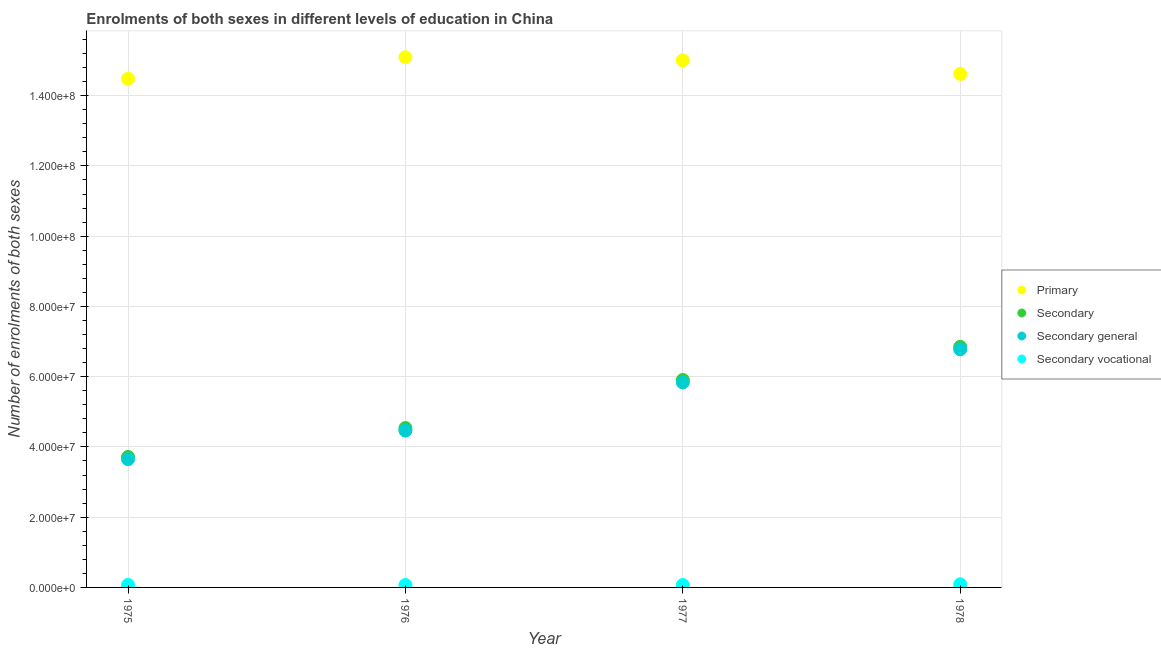How many different coloured dotlines are there?
Your answer should be very brief. 4. Is the number of dotlines equal to the number of legend labels?
Your answer should be very brief. Yes. What is the number of enrolments in secondary general education in 1975?
Make the answer very short. 3.65e+07. Across all years, what is the maximum number of enrolments in secondary vocational education?
Your answer should be compact. 8.89e+05. Across all years, what is the minimum number of enrolments in primary education?
Offer a very short reply. 1.45e+08. In which year was the number of enrolments in secondary education maximum?
Your answer should be very brief. 1978. In which year was the number of enrolments in secondary general education minimum?
Make the answer very short. 1975. What is the total number of enrolments in secondary general education in the graph?
Your response must be concise. 2.07e+08. What is the difference between the number of enrolments in secondary general education in 1975 and that in 1978?
Give a very brief answer. -3.13e+07. What is the difference between the number of enrolments in secondary education in 1978 and the number of enrolments in secondary vocational education in 1977?
Ensure brevity in your answer.  6.78e+07. What is the average number of enrolments in secondary general education per year?
Provide a succinct answer. 5.18e+07. In the year 1978, what is the difference between the number of enrolments in secondary vocational education and number of enrolments in primary education?
Offer a terse response. -1.45e+08. In how many years, is the number of enrolments in secondary general education greater than 140000000?
Offer a terse response. 0. What is the ratio of the number of enrolments in secondary vocational education in 1976 to that in 1977?
Your response must be concise. 1. Is the number of enrolments in secondary general education in 1975 less than that in 1976?
Offer a very short reply. Yes. What is the difference between the highest and the second highest number of enrolments in secondary education?
Your response must be concise. 9.43e+06. What is the difference between the highest and the lowest number of enrolments in secondary general education?
Offer a terse response. 3.13e+07. In how many years, is the number of enrolments in secondary general education greater than the average number of enrolments in secondary general education taken over all years?
Keep it short and to the point. 2. Is the sum of the number of enrolments in secondary education in 1976 and 1977 greater than the maximum number of enrolments in secondary general education across all years?
Ensure brevity in your answer.  Yes. Is it the case that in every year, the sum of the number of enrolments in secondary vocational education and number of enrolments in secondary education is greater than the sum of number of enrolments in secondary general education and number of enrolments in primary education?
Offer a very short reply. Yes. Is it the case that in every year, the sum of the number of enrolments in primary education and number of enrolments in secondary education is greater than the number of enrolments in secondary general education?
Your answer should be very brief. Yes. Does the number of enrolments in secondary vocational education monotonically increase over the years?
Your answer should be very brief. No. How many dotlines are there?
Your answer should be very brief. 4. Are the values on the major ticks of Y-axis written in scientific E-notation?
Make the answer very short. Yes. Does the graph contain any zero values?
Make the answer very short. No. Does the graph contain grids?
Your response must be concise. Yes. How many legend labels are there?
Offer a very short reply. 4. How are the legend labels stacked?
Ensure brevity in your answer.  Vertical. What is the title of the graph?
Keep it short and to the point. Enrolments of both sexes in different levels of education in China. What is the label or title of the X-axis?
Provide a succinct answer. Year. What is the label or title of the Y-axis?
Offer a terse response. Number of enrolments of both sexes. What is the Number of enrolments of both sexes of Primary in 1975?
Make the answer very short. 1.45e+08. What is the Number of enrolments of both sexes of Secondary in 1975?
Your answer should be very brief. 3.71e+07. What is the Number of enrolments of both sexes in Secondary general in 1975?
Make the answer very short. 3.65e+07. What is the Number of enrolments of both sexes in Secondary vocational in 1975?
Offer a terse response. 7.07e+05. What is the Number of enrolments of both sexes of Primary in 1976?
Your response must be concise. 1.51e+08. What is the Number of enrolments of both sexes of Secondary in 1976?
Make the answer very short. 4.54e+07. What is the Number of enrolments of both sexes in Secondary general in 1976?
Your answer should be compact. 4.47e+07. What is the Number of enrolments of both sexes of Secondary vocational in 1976?
Your answer should be compact. 6.90e+05. What is the Number of enrolments of both sexes in Primary in 1977?
Your answer should be compact. 1.50e+08. What is the Number of enrolments of both sexes in Secondary in 1977?
Keep it short and to the point. 5.91e+07. What is the Number of enrolments of both sexes of Secondary general in 1977?
Offer a very short reply. 5.84e+07. What is the Number of enrolments of both sexes of Secondary vocational in 1977?
Your answer should be compact. 6.89e+05. What is the Number of enrolments of both sexes of Primary in 1978?
Offer a very short reply. 1.46e+08. What is the Number of enrolments of both sexes in Secondary in 1978?
Give a very brief answer. 6.85e+07. What is the Number of enrolments of both sexes of Secondary general in 1978?
Provide a short and direct response. 6.78e+07. What is the Number of enrolments of both sexes of Secondary vocational in 1978?
Give a very brief answer. 8.89e+05. Across all years, what is the maximum Number of enrolments of both sexes in Primary?
Your answer should be very brief. 1.51e+08. Across all years, what is the maximum Number of enrolments of both sexes in Secondary?
Ensure brevity in your answer.  6.85e+07. Across all years, what is the maximum Number of enrolments of both sexes of Secondary general?
Provide a short and direct response. 6.78e+07. Across all years, what is the maximum Number of enrolments of both sexes in Secondary vocational?
Provide a short and direct response. 8.89e+05. Across all years, what is the minimum Number of enrolments of both sexes in Primary?
Provide a short and direct response. 1.45e+08. Across all years, what is the minimum Number of enrolments of both sexes in Secondary?
Keep it short and to the point. 3.71e+07. Across all years, what is the minimum Number of enrolments of both sexes of Secondary general?
Offer a very short reply. 3.65e+07. Across all years, what is the minimum Number of enrolments of both sexes in Secondary vocational?
Your response must be concise. 6.89e+05. What is the total Number of enrolments of both sexes in Primary in the graph?
Offer a very short reply. 5.92e+08. What is the total Number of enrolments of both sexes in Secondary in the graph?
Keep it short and to the point. 2.10e+08. What is the total Number of enrolments of both sexes in Secondary general in the graph?
Offer a terse response. 2.07e+08. What is the total Number of enrolments of both sexes in Secondary vocational in the graph?
Your answer should be very brief. 2.98e+06. What is the difference between the Number of enrolments of both sexes of Primary in 1975 and that in 1976?
Offer a terse response. -6.13e+06. What is the difference between the Number of enrolments of both sexes in Secondary in 1975 and that in 1976?
Provide a succinct answer. -8.23e+06. What is the difference between the Number of enrolments of both sexes of Secondary general in 1975 and that in 1976?
Give a very brief answer. -8.16e+06. What is the difference between the Number of enrolments of both sexes in Secondary vocational in 1975 and that in 1976?
Your response must be concise. 1.74e+04. What is the difference between the Number of enrolments of both sexes in Primary in 1975 and that in 1977?
Provide a succinct answer. -5.24e+06. What is the difference between the Number of enrolments of both sexes in Secondary in 1975 and that in 1977?
Provide a succinct answer. -2.19e+07. What is the difference between the Number of enrolments of both sexes of Secondary general in 1975 and that in 1977?
Offer a very short reply. -2.19e+07. What is the difference between the Number of enrolments of both sexes in Secondary vocational in 1975 and that in 1977?
Provide a succinct answer. 1.81e+04. What is the difference between the Number of enrolments of both sexes in Primary in 1975 and that in 1978?
Keep it short and to the point. -1.36e+06. What is the difference between the Number of enrolments of both sexes of Secondary in 1975 and that in 1978?
Ensure brevity in your answer.  -3.14e+07. What is the difference between the Number of enrolments of both sexes in Secondary general in 1975 and that in 1978?
Offer a terse response. -3.13e+07. What is the difference between the Number of enrolments of both sexes of Secondary vocational in 1975 and that in 1978?
Your response must be concise. -1.82e+05. What is the difference between the Number of enrolments of both sexes in Primary in 1976 and that in 1977?
Keep it short and to the point. 8.86e+05. What is the difference between the Number of enrolments of both sexes of Secondary in 1976 and that in 1977?
Your answer should be compact. -1.37e+07. What is the difference between the Number of enrolments of both sexes in Secondary general in 1976 and that in 1977?
Offer a terse response. -1.37e+07. What is the difference between the Number of enrolments of both sexes in Secondary vocational in 1976 and that in 1977?
Make the answer very short. 675. What is the difference between the Number of enrolments of both sexes in Primary in 1976 and that in 1978?
Offer a very short reply. 4.76e+06. What is the difference between the Number of enrolments of both sexes in Secondary in 1976 and that in 1978?
Give a very brief answer. -2.31e+07. What is the difference between the Number of enrolments of both sexes in Secondary general in 1976 and that in 1978?
Provide a short and direct response. -2.31e+07. What is the difference between the Number of enrolments of both sexes of Secondary vocational in 1976 and that in 1978?
Your answer should be very brief. -1.99e+05. What is the difference between the Number of enrolments of both sexes in Primary in 1977 and that in 1978?
Make the answer very short. 3.88e+06. What is the difference between the Number of enrolments of both sexes in Secondary in 1977 and that in 1978?
Provide a short and direct response. -9.43e+06. What is the difference between the Number of enrolments of both sexes in Secondary general in 1977 and that in 1978?
Provide a short and direct response. -9.43e+06. What is the difference between the Number of enrolments of both sexes in Secondary vocational in 1977 and that in 1978?
Make the answer very short. -2.00e+05. What is the difference between the Number of enrolments of both sexes in Primary in 1975 and the Number of enrolments of both sexes in Secondary in 1976?
Make the answer very short. 9.94e+07. What is the difference between the Number of enrolments of both sexes of Primary in 1975 and the Number of enrolments of both sexes of Secondary general in 1976?
Provide a short and direct response. 1.00e+08. What is the difference between the Number of enrolments of both sexes of Primary in 1975 and the Number of enrolments of both sexes of Secondary vocational in 1976?
Provide a short and direct response. 1.44e+08. What is the difference between the Number of enrolments of both sexes of Secondary in 1975 and the Number of enrolments of both sexes of Secondary general in 1976?
Your response must be concise. -7.52e+06. What is the difference between the Number of enrolments of both sexes in Secondary in 1975 and the Number of enrolments of both sexes in Secondary vocational in 1976?
Provide a short and direct response. 3.64e+07. What is the difference between the Number of enrolments of both sexes in Secondary general in 1975 and the Number of enrolments of both sexes in Secondary vocational in 1976?
Your answer should be very brief. 3.58e+07. What is the difference between the Number of enrolments of both sexes in Primary in 1975 and the Number of enrolments of both sexes in Secondary in 1977?
Your response must be concise. 8.58e+07. What is the difference between the Number of enrolments of both sexes in Primary in 1975 and the Number of enrolments of both sexes in Secondary general in 1977?
Your response must be concise. 8.64e+07. What is the difference between the Number of enrolments of both sexes in Primary in 1975 and the Number of enrolments of both sexes in Secondary vocational in 1977?
Offer a terse response. 1.44e+08. What is the difference between the Number of enrolments of both sexes in Secondary in 1975 and the Number of enrolments of both sexes in Secondary general in 1977?
Your answer should be compact. -2.12e+07. What is the difference between the Number of enrolments of both sexes in Secondary in 1975 and the Number of enrolments of both sexes in Secondary vocational in 1977?
Make the answer very short. 3.64e+07. What is the difference between the Number of enrolments of both sexes in Secondary general in 1975 and the Number of enrolments of both sexes in Secondary vocational in 1977?
Your response must be concise. 3.58e+07. What is the difference between the Number of enrolments of both sexes in Primary in 1975 and the Number of enrolments of both sexes in Secondary in 1978?
Your answer should be very brief. 7.63e+07. What is the difference between the Number of enrolments of both sexes of Primary in 1975 and the Number of enrolments of both sexes of Secondary general in 1978?
Your answer should be very brief. 7.70e+07. What is the difference between the Number of enrolments of both sexes of Primary in 1975 and the Number of enrolments of both sexes of Secondary vocational in 1978?
Your response must be concise. 1.44e+08. What is the difference between the Number of enrolments of both sexes in Secondary in 1975 and the Number of enrolments of both sexes in Secondary general in 1978?
Keep it short and to the point. -3.07e+07. What is the difference between the Number of enrolments of both sexes in Secondary in 1975 and the Number of enrolments of both sexes in Secondary vocational in 1978?
Ensure brevity in your answer.  3.62e+07. What is the difference between the Number of enrolments of both sexes of Secondary general in 1975 and the Number of enrolments of both sexes of Secondary vocational in 1978?
Offer a terse response. 3.56e+07. What is the difference between the Number of enrolments of both sexes in Primary in 1976 and the Number of enrolments of both sexes in Secondary in 1977?
Your answer should be very brief. 9.19e+07. What is the difference between the Number of enrolments of both sexes in Primary in 1976 and the Number of enrolments of both sexes in Secondary general in 1977?
Provide a succinct answer. 9.26e+07. What is the difference between the Number of enrolments of both sexes of Primary in 1976 and the Number of enrolments of both sexes of Secondary vocational in 1977?
Provide a short and direct response. 1.50e+08. What is the difference between the Number of enrolments of both sexes in Secondary in 1976 and the Number of enrolments of both sexes in Secondary general in 1977?
Your response must be concise. -1.30e+07. What is the difference between the Number of enrolments of both sexes of Secondary in 1976 and the Number of enrolments of both sexes of Secondary vocational in 1977?
Offer a very short reply. 4.47e+07. What is the difference between the Number of enrolments of both sexes of Secondary general in 1976 and the Number of enrolments of both sexes of Secondary vocational in 1977?
Provide a succinct answer. 4.40e+07. What is the difference between the Number of enrolments of both sexes of Primary in 1976 and the Number of enrolments of both sexes of Secondary in 1978?
Give a very brief answer. 8.25e+07. What is the difference between the Number of enrolments of both sexes in Primary in 1976 and the Number of enrolments of both sexes in Secondary general in 1978?
Provide a short and direct response. 8.31e+07. What is the difference between the Number of enrolments of both sexes of Primary in 1976 and the Number of enrolments of both sexes of Secondary vocational in 1978?
Provide a succinct answer. 1.50e+08. What is the difference between the Number of enrolments of both sexes of Secondary in 1976 and the Number of enrolments of both sexes of Secondary general in 1978?
Make the answer very short. -2.24e+07. What is the difference between the Number of enrolments of both sexes in Secondary in 1976 and the Number of enrolments of both sexes in Secondary vocational in 1978?
Offer a very short reply. 4.45e+07. What is the difference between the Number of enrolments of both sexes in Secondary general in 1976 and the Number of enrolments of both sexes in Secondary vocational in 1978?
Make the answer very short. 4.38e+07. What is the difference between the Number of enrolments of both sexes of Primary in 1977 and the Number of enrolments of both sexes of Secondary in 1978?
Offer a very short reply. 8.16e+07. What is the difference between the Number of enrolments of both sexes of Primary in 1977 and the Number of enrolments of both sexes of Secondary general in 1978?
Your response must be concise. 8.23e+07. What is the difference between the Number of enrolments of both sexes in Primary in 1977 and the Number of enrolments of both sexes in Secondary vocational in 1978?
Your answer should be very brief. 1.49e+08. What is the difference between the Number of enrolments of both sexes of Secondary in 1977 and the Number of enrolments of both sexes of Secondary general in 1978?
Give a very brief answer. -8.74e+06. What is the difference between the Number of enrolments of both sexes in Secondary in 1977 and the Number of enrolments of both sexes in Secondary vocational in 1978?
Provide a succinct answer. 5.82e+07. What is the difference between the Number of enrolments of both sexes in Secondary general in 1977 and the Number of enrolments of both sexes in Secondary vocational in 1978?
Your answer should be very brief. 5.75e+07. What is the average Number of enrolments of both sexes of Primary per year?
Offer a very short reply. 1.48e+08. What is the average Number of enrolments of both sexes in Secondary per year?
Offer a terse response. 5.25e+07. What is the average Number of enrolments of both sexes in Secondary general per year?
Offer a terse response. 5.18e+07. What is the average Number of enrolments of both sexes of Secondary vocational per year?
Make the answer very short. 7.44e+05. In the year 1975, what is the difference between the Number of enrolments of both sexes in Primary and Number of enrolments of both sexes in Secondary?
Make the answer very short. 1.08e+08. In the year 1975, what is the difference between the Number of enrolments of both sexes in Primary and Number of enrolments of both sexes in Secondary general?
Give a very brief answer. 1.08e+08. In the year 1975, what is the difference between the Number of enrolments of both sexes in Primary and Number of enrolments of both sexes in Secondary vocational?
Provide a short and direct response. 1.44e+08. In the year 1975, what is the difference between the Number of enrolments of both sexes of Secondary and Number of enrolments of both sexes of Secondary general?
Your response must be concise. 6.34e+05. In the year 1975, what is the difference between the Number of enrolments of both sexes in Secondary and Number of enrolments of both sexes in Secondary vocational?
Your response must be concise. 3.64e+07. In the year 1975, what is the difference between the Number of enrolments of both sexes in Secondary general and Number of enrolments of both sexes in Secondary vocational?
Your response must be concise. 3.58e+07. In the year 1976, what is the difference between the Number of enrolments of both sexes in Primary and Number of enrolments of both sexes in Secondary?
Your answer should be very brief. 1.06e+08. In the year 1976, what is the difference between the Number of enrolments of both sexes of Primary and Number of enrolments of both sexes of Secondary general?
Offer a terse response. 1.06e+08. In the year 1976, what is the difference between the Number of enrolments of both sexes in Primary and Number of enrolments of both sexes in Secondary vocational?
Make the answer very short. 1.50e+08. In the year 1976, what is the difference between the Number of enrolments of both sexes in Secondary and Number of enrolments of both sexes in Secondary general?
Your response must be concise. 7.07e+05. In the year 1976, what is the difference between the Number of enrolments of both sexes in Secondary and Number of enrolments of both sexes in Secondary vocational?
Your answer should be very brief. 4.47e+07. In the year 1976, what is the difference between the Number of enrolments of both sexes of Secondary general and Number of enrolments of both sexes of Secondary vocational?
Provide a succinct answer. 4.40e+07. In the year 1977, what is the difference between the Number of enrolments of both sexes of Primary and Number of enrolments of both sexes of Secondary?
Offer a very short reply. 9.10e+07. In the year 1977, what is the difference between the Number of enrolments of both sexes of Primary and Number of enrolments of both sexes of Secondary general?
Your response must be concise. 9.17e+07. In the year 1977, what is the difference between the Number of enrolments of both sexes of Primary and Number of enrolments of both sexes of Secondary vocational?
Your answer should be compact. 1.49e+08. In the year 1977, what is the difference between the Number of enrolments of both sexes in Secondary and Number of enrolments of both sexes in Secondary general?
Offer a very short reply. 6.90e+05. In the year 1977, what is the difference between the Number of enrolments of both sexes in Secondary and Number of enrolments of both sexes in Secondary vocational?
Your response must be concise. 5.84e+07. In the year 1977, what is the difference between the Number of enrolments of both sexes of Secondary general and Number of enrolments of both sexes of Secondary vocational?
Make the answer very short. 5.77e+07. In the year 1978, what is the difference between the Number of enrolments of both sexes in Primary and Number of enrolments of both sexes in Secondary?
Offer a very short reply. 7.77e+07. In the year 1978, what is the difference between the Number of enrolments of both sexes of Primary and Number of enrolments of both sexes of Secondary general?
Keep it short and to the point. 7.84e+07. In the year 1978, what is the difference between the Number of enrolments of both sexes in Primary and Number of enrolments of both sexes in Secondary vocational?
Your answer should be compact. 1.45e+08. In the year 1978, what is the difference between the Number of enrolments of both sexes of Secondary and Number of enrolments of both sexes of Secondary general?
Ensure brevity in your answer.  6.89e+05. In the year 1978, what is the difference between the Number of enrolments of both sexes of Secondary and Number of enrolments of both sexes of Secondary vocational?
Your answer should be compact. 6.76e+07. In the year 1978, what is the difference between the Number of enrolments of both sexes of Secondary general and Number of enrolments of both sexes of Secondary vocational?
Ensure brevity in your answer.  6.69e+07. What is the ratio of the Number of enrolments of both sexes in Primary in 1975 to that in 1976?
Offer a very short reply. 0.96. What is the ratio of the Number of enrolments of both sexes of Secondary in 1975 to that in 1976?
Give a very brief answer. 0.82. What is the ratio of the Number of enrolments of both sexes of Secondary general in 1975 to that in 1976?
Give a very brief answer. 0.82. What is the ratio of the Number of enrolments of both sexes in Secondary vocational in 1975 to that in 1976?
Offer a very short reply. 1.03. What is the ratio of the Number of enrolments of both sexes in Primary in 1975 to that in 1977?
Offer a terse response. 0.97. What is the ratio of the Number of enrolments of both sexes of Secondary in 1975 to that in 1977?
Keep it short and to the point. 0.63. What is the ratio of the Number of enrolments of both sexes of Secondary general in 1975 to that in 1977?
Provide a succinct answer. 0.63. What is the ratio of the Number of enrolments of both sexes of Secondary vocational in 1975 to that in 1977?
Ensure brevity in your answer.  1.03. What is the ratio of the Number of enrolments of both sexes in Primary in 1975 to that in 1978?
Provide a short and direct response. 0.99. What is the ratio of the Number of enrolments of both sexes in Secondary in 1975 to that in 1978?
Provide a succinct answer. 0.54. What is the ratio of the Number of enrolments of both sexes in Secondary general in 1975 to that in 1978?
Offer a very short reply. 0.54. What is the ratio of the Number of enrolments of both sexes in Secondary vocational in 1975 to that in 1978?
Offer a terse response. 0.8. What is the ratio of the Number of enrolments of both sexes in Primary in 1976 to that in 1977?
Ensure brevity in your answer.  1.01. What is the ratio of the Number of enrolments of both sexes in Secondary in 1976 to that in 1977?
Provide a short and direct response. 0.77. What is the ratio of the Number of enrolments of both sexes of Secondary general in 1976 to that in 1977?
Your answer should be very brief. 0.77. What is the ratio of the Number of enrolments of both sexes in Secondary vocational in 1976 to that in 1977?
Your answer should be compact. 1. What is the ratio of the Number of enrolments of both sexes in Primary in 1976 to that in 1978?
Provide a succinct answer. 1.03. What is the ratio of the Number of enrolments of both sexes in Secondary in 1976 to that in 1978?
Provide a short and direct response. 0.66. What is the ratio of the Number of enrolments of both sexes of Secondary general in 1976 to that in 1978?
Your answer should be compact. 0.66. What is the ratio of the Number of enrolments of both sexes of Secondary vocational in 1976 to that in 1978?
Keep it short and to the point. 0.78. What is the ratio of the Number of enrolments of both sexes of Primary in 1977 to that in 1978?
Make the answer very short. 1.03. What is the ratio of the Number of enrolments of both sexes of Secondary in 1977 to that in 1978?
Your response must be concise. 0.86. What is the ratio of the Number of enrolments of both sexes in Secondary general in 1977 to that in 1978?
Your response must be concise. 0.86. What is the ratio of the Number of enrolments of both sexes of Secondary vocational in 1977 to that in 1978?
Provide a short and direct response. 0.78. What is the difference between the highest and the second highest Number of enrolments of both sexes of Primary?
Offer a very short reply. 8.86e+05. What is the difference between the highest and the second highest Number of enrolments of both sexes of Secondary?
Offer a terse response. 9.43e+06. What is the difference between the highest and the second highest Number of enrolments of both sexes of Secondary general?
Keep it short and to the point. 9.43e+06. What is the difference between the highest and the second highest Number of enrolments of both sexes of Secondary vocational?
Offer a very short reply. 1.82e+05. What is the difference between the highest and the lowest Number of enrolments of both sexes in Primary?
Provide a short and direct response. 6.13e+06. What is the difference between the highest and the lowest Number of enrolments of both sexes of Secondary?
Ensure brevity in your answer.  3.14e+07. What is the difference between the highest and the lowest Number of enrolments of both sexes of Secondary general?
Offer a very short reply. 3.13e+07. What is the difference between the highest and the lowest Number of enrolments of both sexes of Secondary vocational?
Make the answer very short. 2.00e+05. 